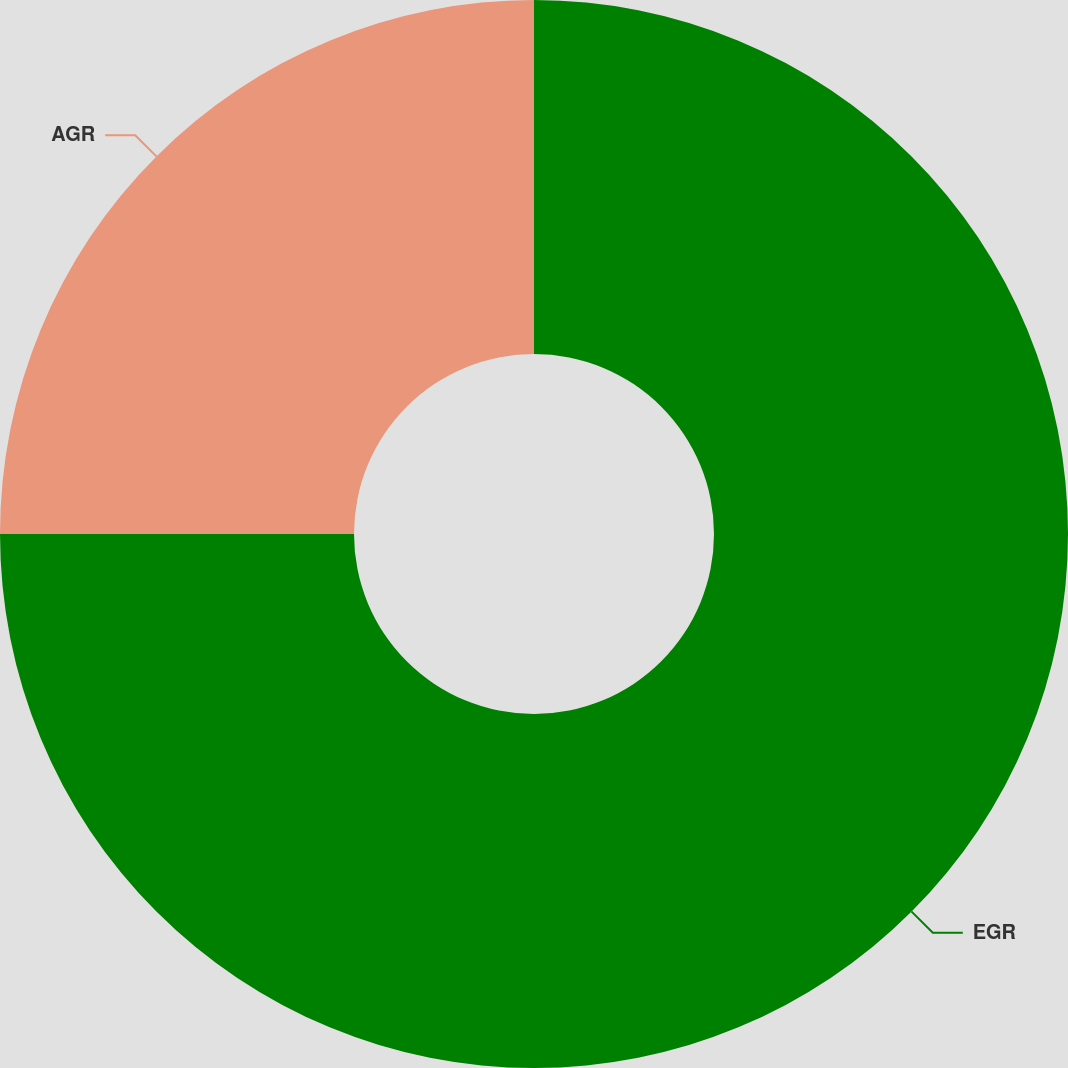Convert chart to OTSL. <chart><loc_0><loc_0><loc_500><loc_500><pie_chart><fcel>EGR<fcel>AGR<nl><fcel>75.0%<fcel>25.0%<nl></chart> 